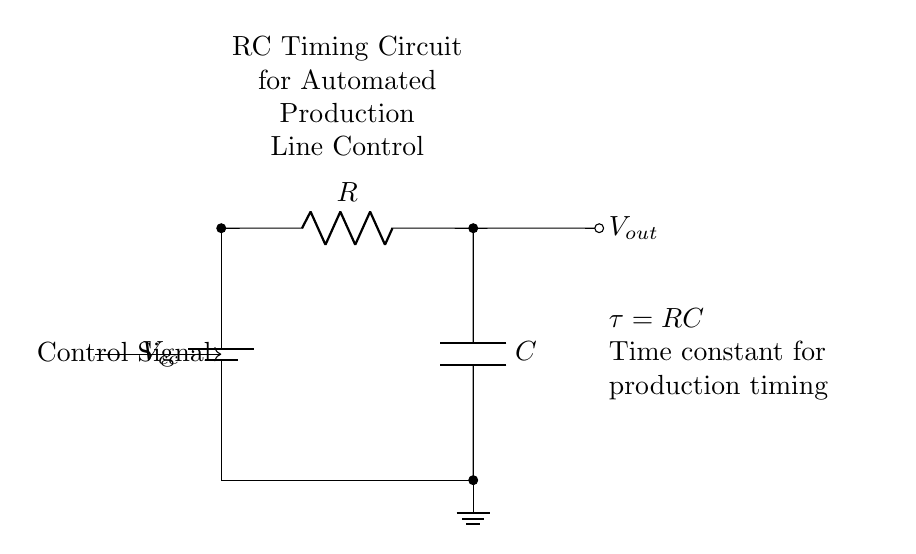What is the power supply voltage? The circuit shows a generic battery symbol labeled as Vcc, which indicates the supply voltage is defined as Vcc without a specific value given.
Answer: Vcc What components are in the circuit? The circuit contains a resistor R and a capacitor C in series, as indicated by their labels. Additionally, there is a battery symbol for the power supply and a ground symbol.
Answer: Resistor and capacitor What is the purpose of the control signal? The control signal is connected to the power supply, indicating it is used to initiate or control the operation of the circuit, likely for activating the timing function for production control.
Answer: To initiate timing What is the time constant of the circuit? The time constant tau (τ) is defined by the formula τ = RC, which represents the product of the resistance (R) and the capacitance (C) in the circuit.
Answer: RC How does the output voltage change during operation? The output voltage Vout will change based on the charging and discharging behavior of the capacitor, which is influenced by the resistance and the control signal. Initially, Vout will rise until it reaches a certain level determined by the circuit parameters.
Answer: It charges and discharges What role does the capacitor play in the timing circuit? The capacitor temporarily stores electrical energy and affects the charging and discharging time constants, which in turn controls the timing of the circuit operation, essential for the automated production line.
Answer: Timing control What happens when the control signal is applied? When the control signal is applied, it activates the circuit allowing the capacitor to begin charging through the resistor, initiating the timing cycle defined by the time constant τ.
Answer: Circuit activates 